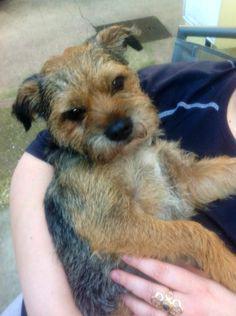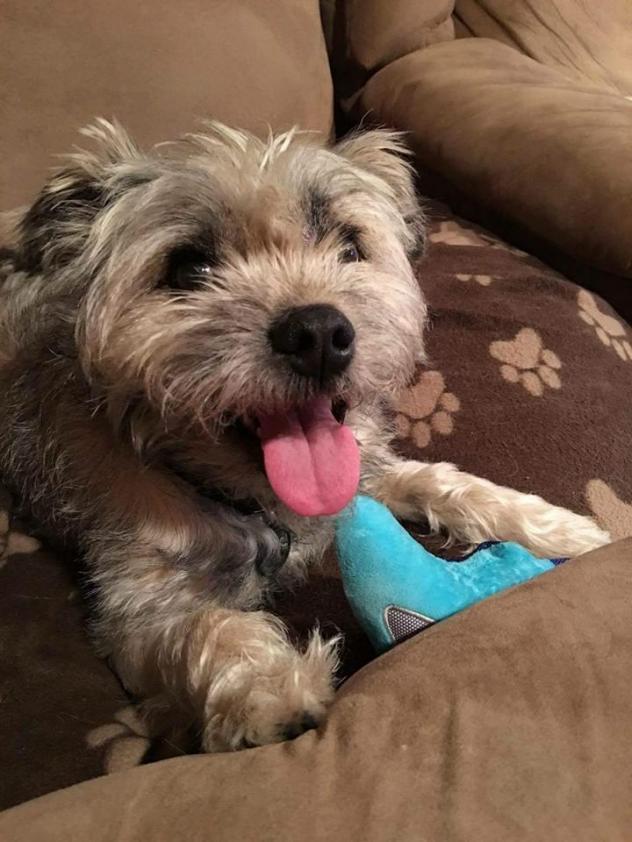The first image is the image on the left, the second image is the image on the right. Considering the images on both sides, is "None of the dogs' tongues are visible." valid? Answer yes or no. No. 